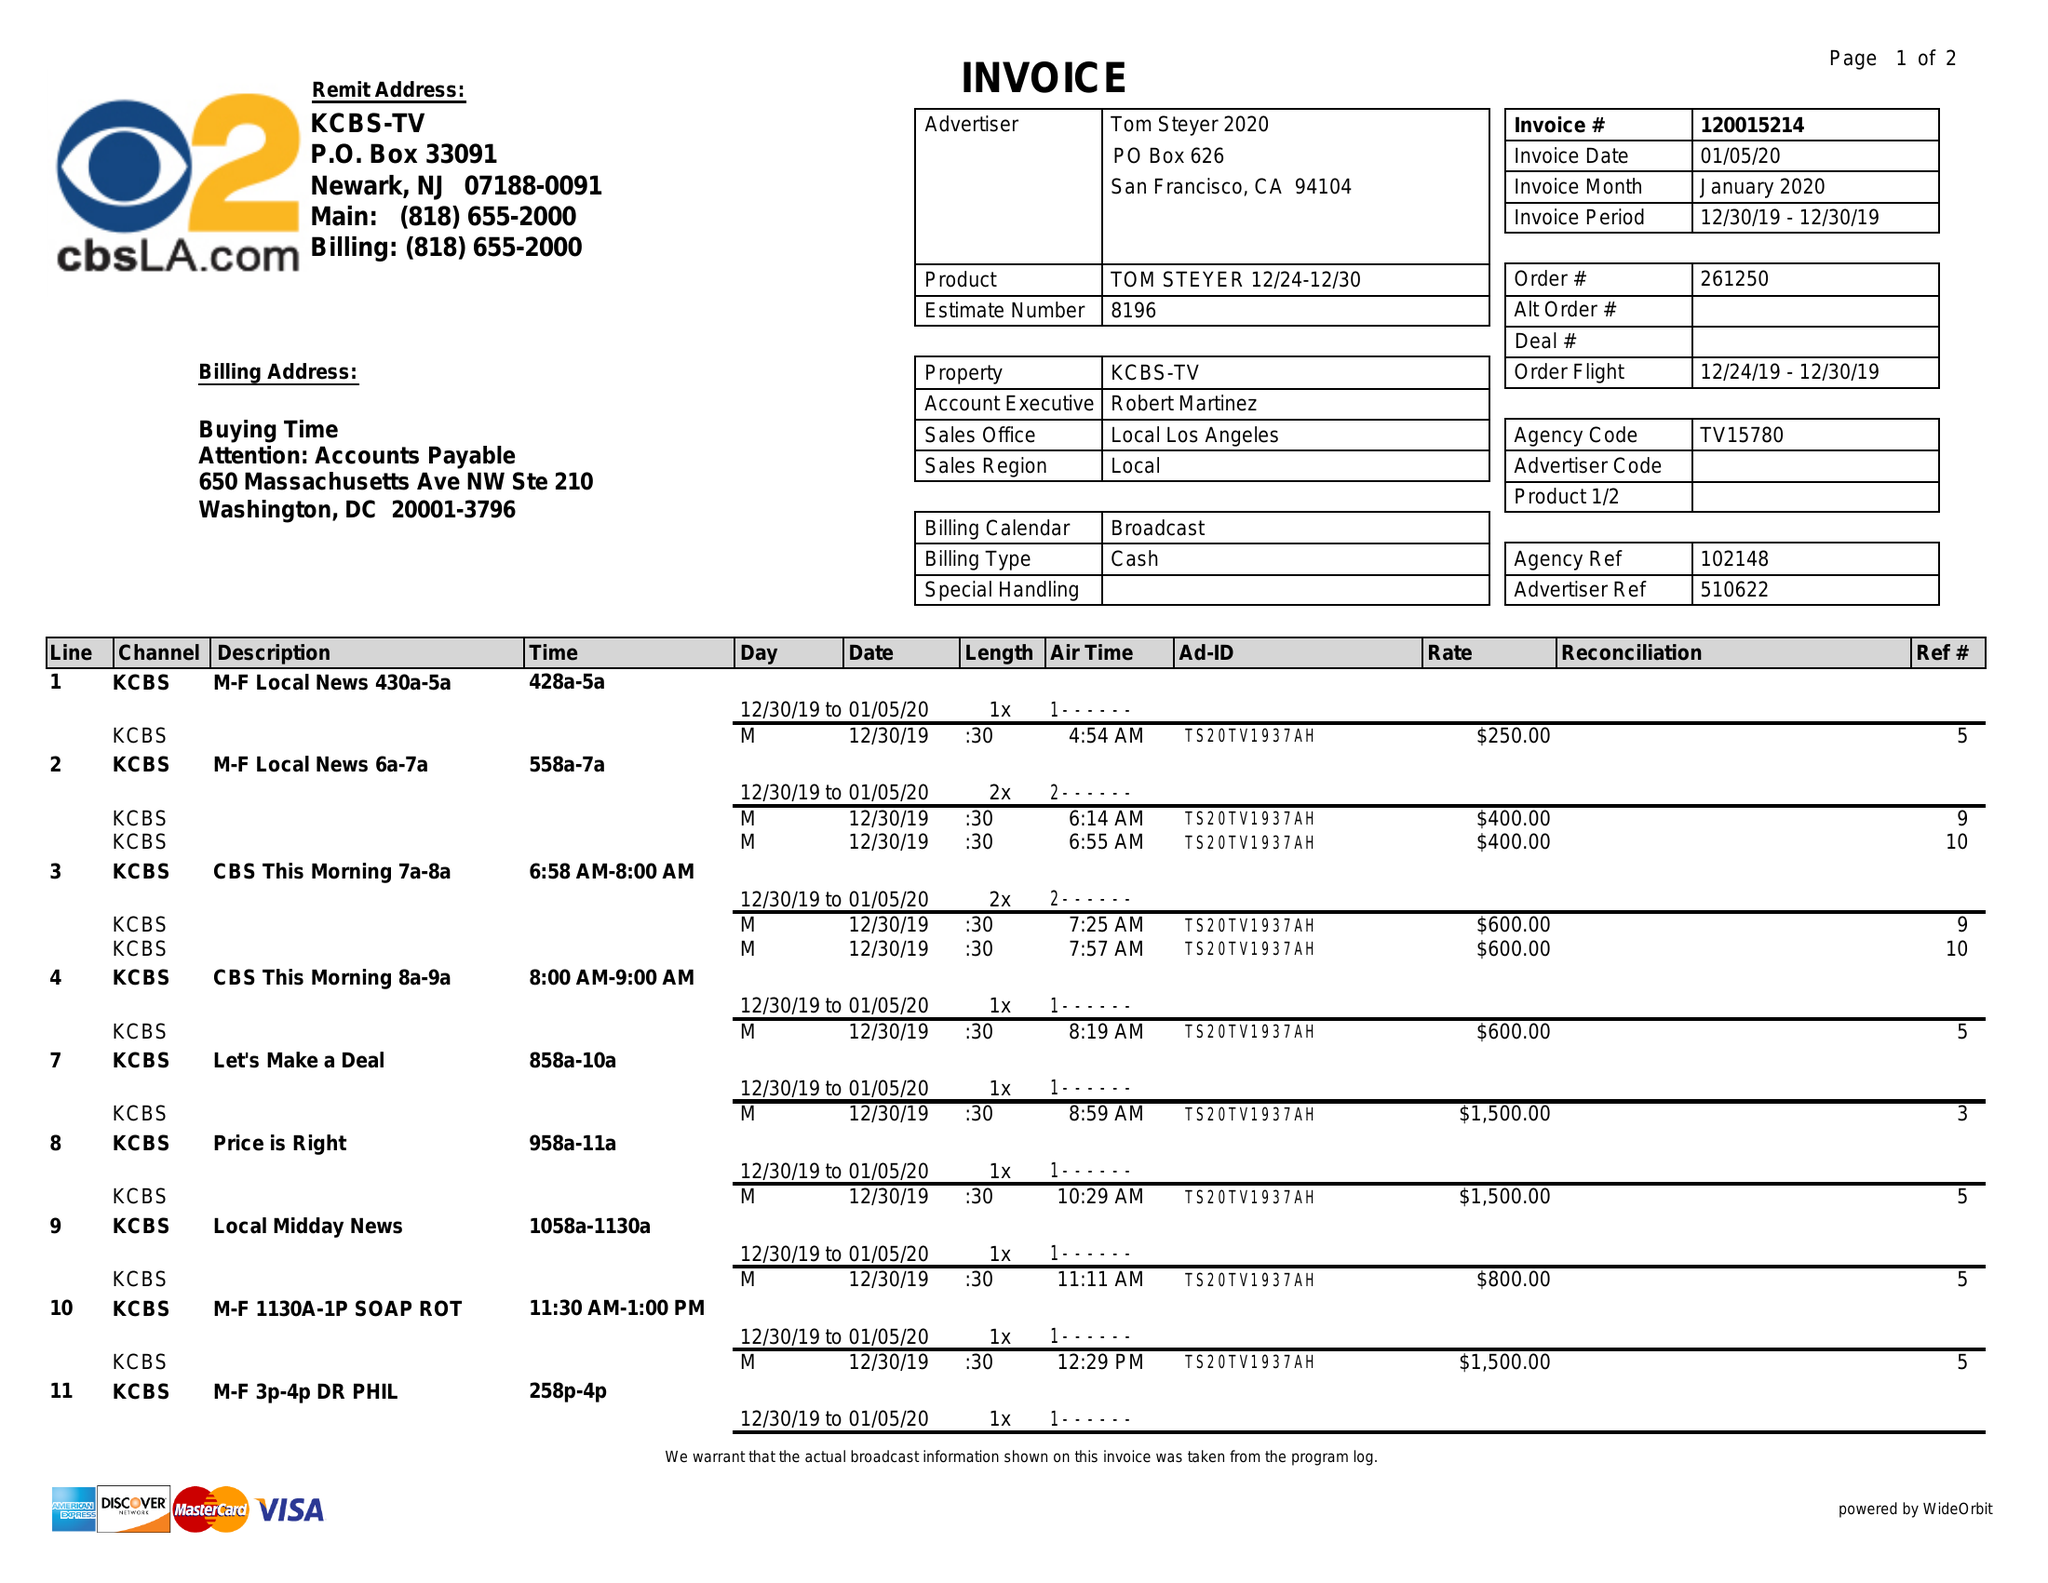What is the value for the gross_amount?
Answer the question using a single word or phrase. 15750.00 